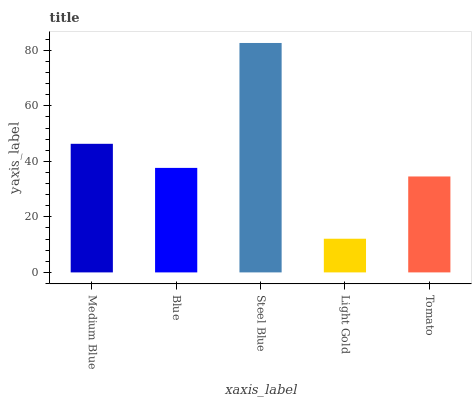Is Light Gold the minimum?
Answer yes or no. Yes. Is Steel Blue the maximum?
Answer yes or no. Yes. Is Blue the minimum?
Answer yes or no. No. Is Blue the maximum?
Answer yes or no. No. Is Medium Blue greater than Blue?
Answer yes or no. Yes. Is Blue less than Medium Blue?
Answer yes or no. Yes. Is Blue greater than Medium Blue?
Answer yes or no. No. Is Medium Blue less than Blue?
Answer yes or no. No. Is Blue the high median?
Answer yes or no. Yes. Is Blue the low median?
Answer yes or no. Yes. Is Light Gold the high median?
Answer yes or no. No. Is Tomato the low median?
Answer yes or no. No. 